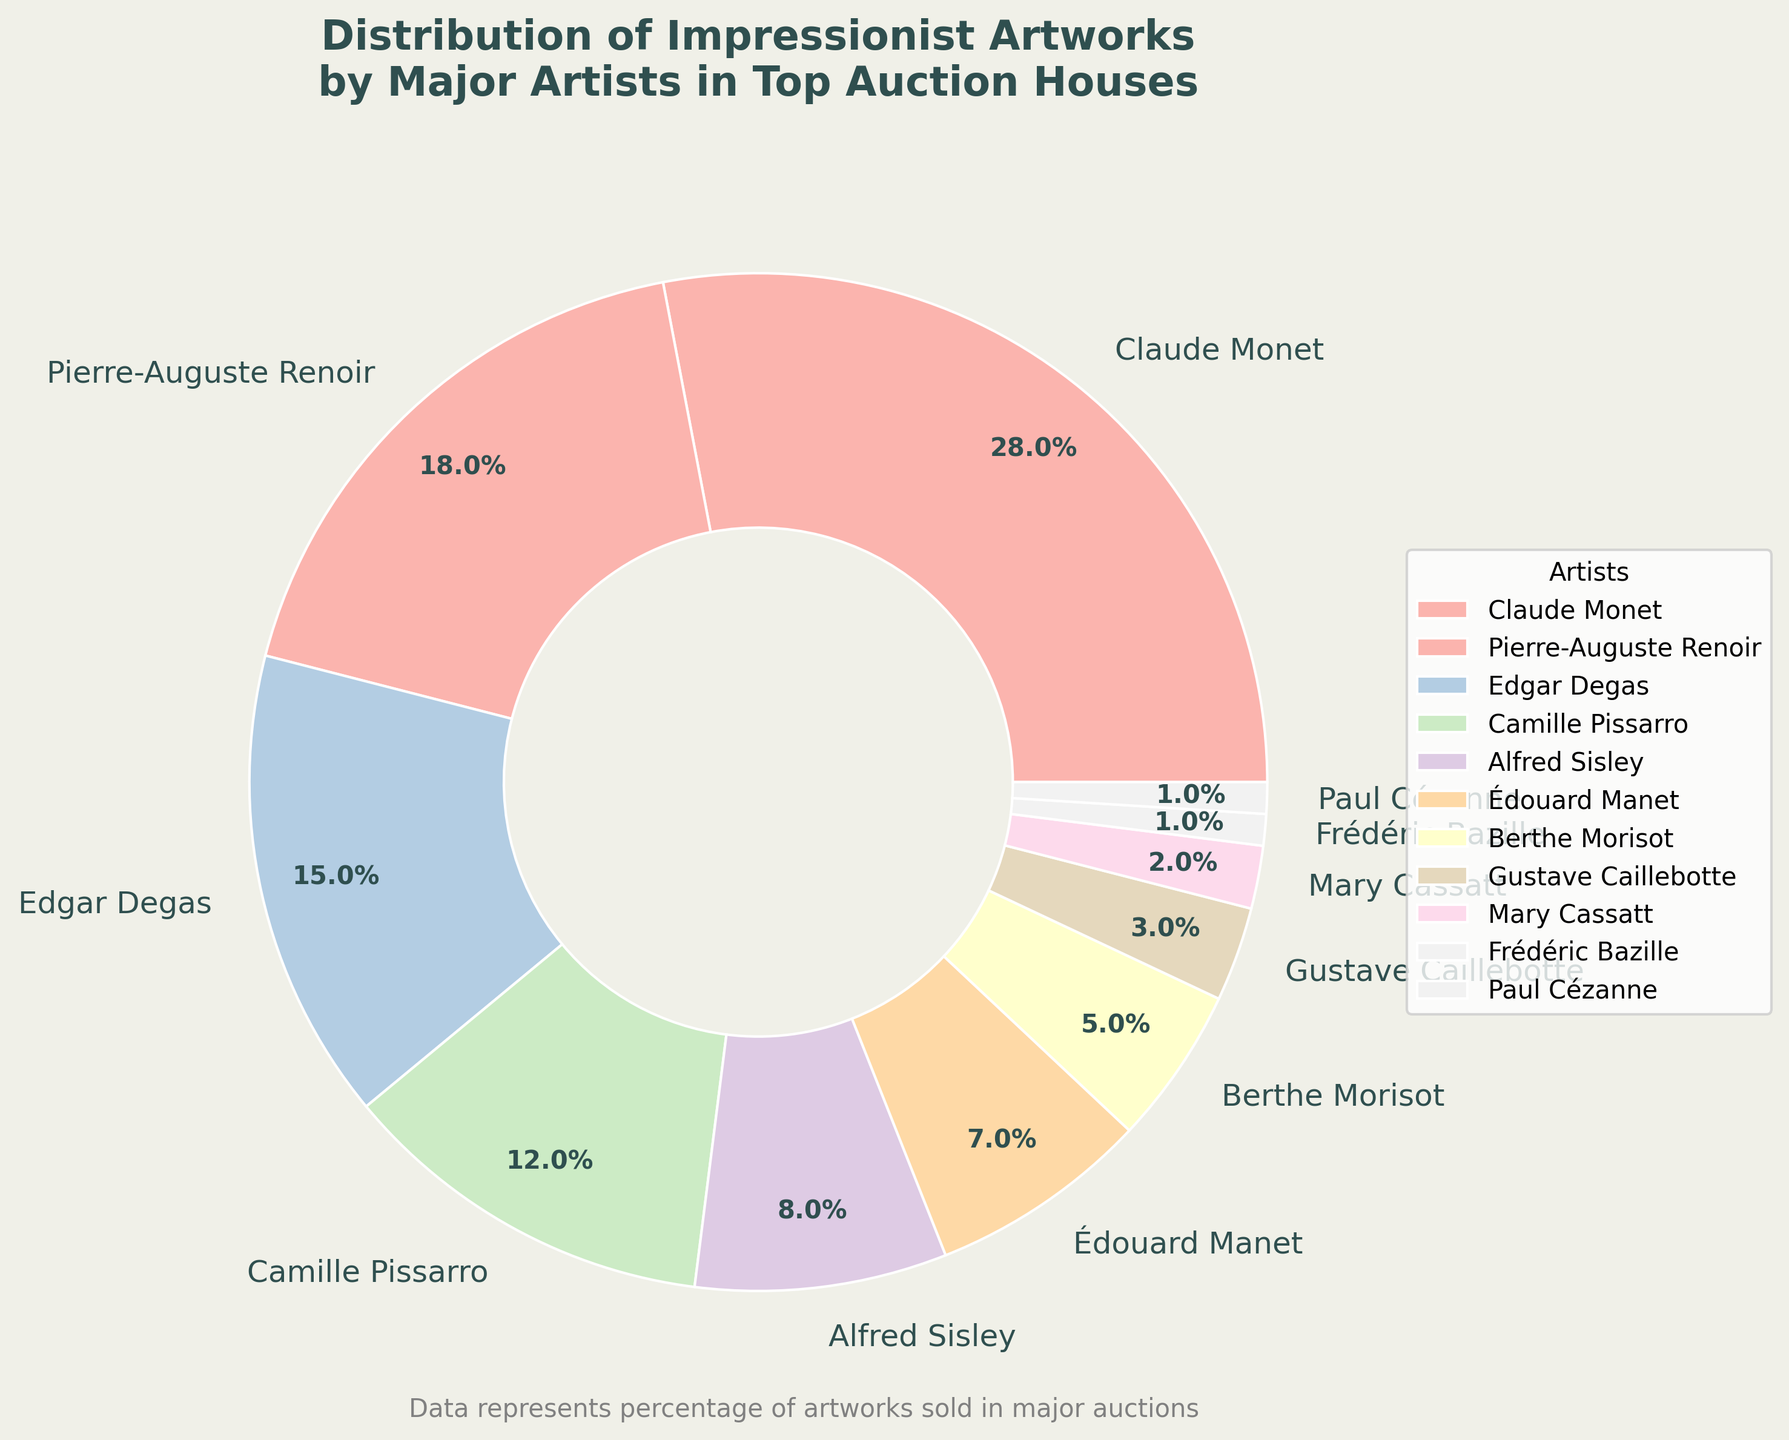What is the combined percentage of artworks by Claude Monet and Pierre-Auguste Renoir? To find the combined percentage, add the percentages of Claude Monet (28%) and Pierre-Auguste Renoir (18%). So, 28% + 18% = 46%
Answer: 46% Which artist has a smaller percentage of artworks sold than Édouard Manet but larger than Berthe Morisot? Édouard Manet has 7% and Berthe Morisot has 5%. The artist with a percentage between 7% and 5% is Alfred Sisley, who has 8%.
Answer: Alfred Sisley Who has contributed the least percentage of Impressionist artworks? The artist with the smallest percentage is Frédéric Bazille with 1%.
Answer: Frédéric Bazille Is Camille Pissarro’s contribution more than double that of Édouard Manet? Camille Pissarro has 12% and Édouard Manet has 7%. Calculate double of Manet's percentage: 7% * 2 = 14%. Since 12% < 14%, Pissarro’s contribution is not more than double Manet's.
Answer: No How does the percentage of artworks by Camille Pissarro compare to that of Edgar Degas? Camille Pissarro has 12% and Edgar Degas has 15%. Since 12% < 15%, Pissarro’s percentage is less than Degas’s percentage.
Answer: Less What is the average percentage of artworks for AlfEd Sisley, Berthe Morisot, and Gustave Caillebotte? Add percentages: 8% (Sisley) + 5% (Morisot) + 3% (Caillebotte) = 16%. The average is 16% / 3 = 5.33%.
Answer: 5.33% Which artist has a higher percentage, Alfred Sisley or Édouard Manet? Alfred Sisley has 8%, and Édouard Manet has 7%, so Sisley has a higher percentage.
Answer: Alfred Sisley What is the total percentage contributed by the three artists with the lowest shares? Add percentages for Mary Cassatt (2%), Frédéric Bazille (1%), and Paul Cézanne (1%). So, 2% + 1% + 1% = 4%.
Answer: 4% What is the difference between the percentage of artworks by Pierre-Auguste Renoir and Berthe Morisot? Calculate the difference: 18% (Renoir) - 5% (Morisot) = 13%.
Answer: 13% How many artists have a percentage of 5% or higher? Artists with percentages 5% or higher are Monet (28%), Renoir (18%), Degas (15%), Pissarro (12%), Sisley (8%), Manet (7%), and Morisot (5%). There are 7 artists.
Answer: 7 